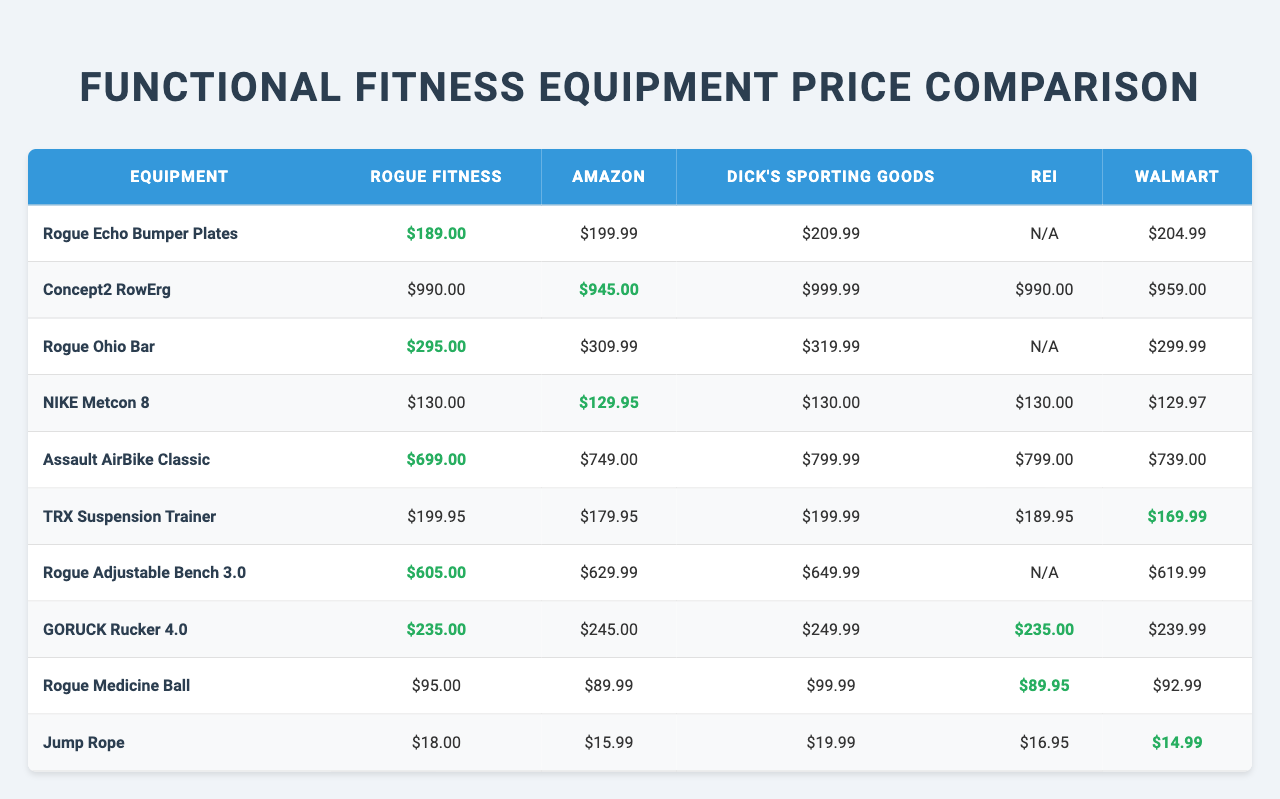What is the price of the Rogue Ohio Bar at Rogue Fitness? The table shows the price for the Rogue Ohio Bar specifically listed under the Rogue Fitness column. The price is $295.00.
Answer: $295.00 Which retailer offers the lowest price for the NIKE Metcon 8? Looking at the NIKE Metcon 8 row, we can see the prices from each retailer. The lowest price is $129.95 at Amazon.
Answer: $129.95 Is the price of the Concept2 RowErg the same across all retailers? By examining the prices for the Concept2 RowErg, we can see different values from each retailer: Rogue Fitness $990.00, Amazon $945.00, Dick's Sporting Goods $999.99, REI $990.00, and Walmart $959.00. Thus, they are not the same.
Answer: No What is the total cost of buying Rogue Echo Bumper Plates and a Jump Rope from Walmart? For Walmart, the price of Rogue Echo Bumper Plates is $204.99 and the Jump Rope is $14.99. Adding these two values gives us a total of $204.99 + $14.99 = $219.98.
Answer: $219.98 What is the average price of the Assault AirBike Classic across all retailers? The prices of the Assault AirBike Classic are $699.00 at Rogue Fitness, $749.00 at Amazon, $799.99 at Dick's Sporting Goods, $799.00 at REI, and $739.00 at Walmart. To find the average, we add these prices together: $699.00 + $749.00 + $799.99 + $799.00 + $739.00 = $3965.99. Dividing by the number of retailers (5) gives us an average of $793.20.
Answer: $793.20 Which equipment has the highest price according to Dick's Sporting Goods? By examining the Dick's Sporting Goods column, the highest price is $999.99 for the Concept2 RowErg.
Answer: $999.99 Is there any equipment that has an "N/A" price listed under REI? Checking the REI column, we see that the Rogue Echo Bumper Plates, Rogue Ohio Bar, and Rogue Adjustable Bench 3.0 have "N/A" listed. Therefore, yes, there is equipment with an "N/A" price.
Answer: Yes Which retailer is consistently the lowest for most equipment? By analyzing the prices across all retailers for each equipment type, Rogue Fitness has the best prices for several items, including the Rogue Echo Bumper Plates, and the Jump Rope. After reviewing, we find that Rogue Fitness has the lowest price for 5 of the items listed, compared to others.
Answer: Rogue Fitness What is the difference in price for the Rogue Medicine Ball between Rogue Fitness and Dick's Sporting Goods? The price of the Rogue Medicine Ball at Rogue Fitness is $95.00 while at Dick's Sporting Goods it is $99.99. The difference is $99.99 - $95.00 = $4.99.
Answer: $4.99 